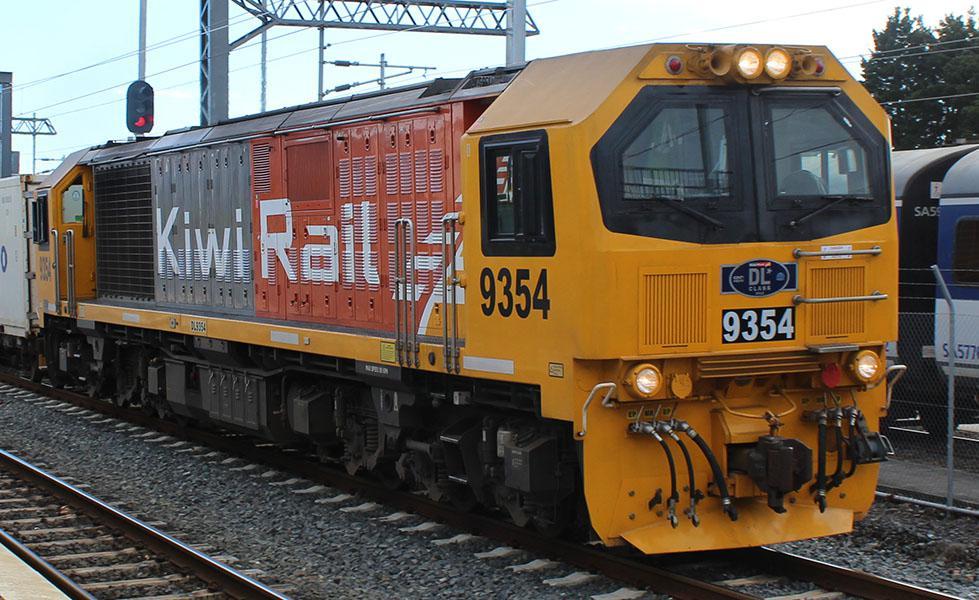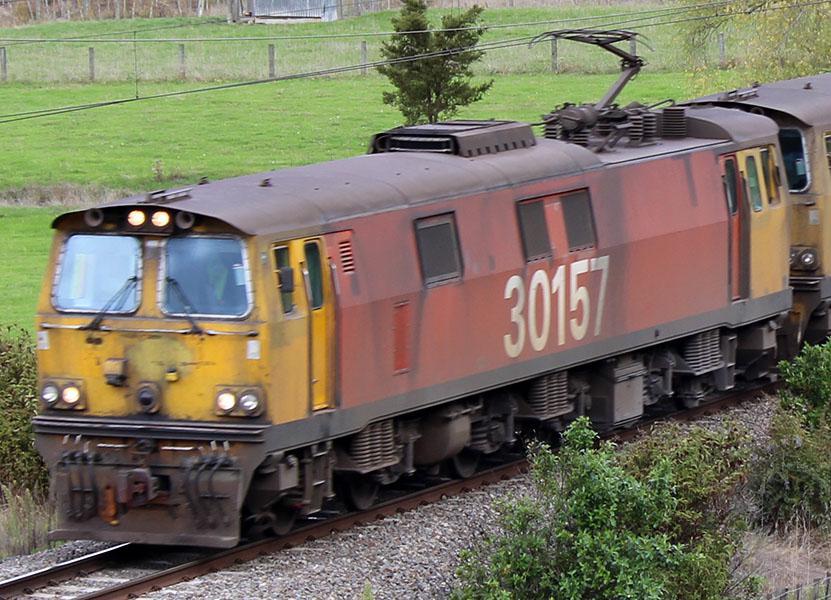The first image is the image on the left, the second image is the image on the right. Examine the images to the left and right. Is the description "The train in both images is yellow and red." accurate? Answer yes or no. Yes. 